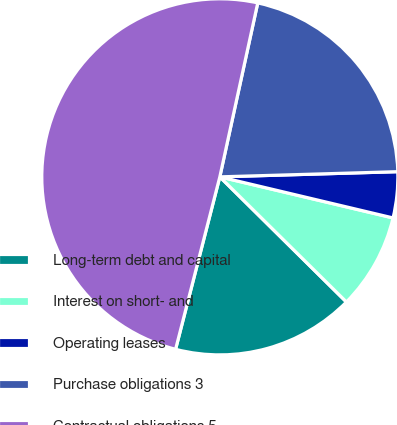Convert chart to OTSL. <chart><loc_0><loc_0><loc_500><loc_500><pie_chart><fcel>Long-term debt and capital<fcel>Interest on short- and<fcel>Operating leases<fcel>Purchase obligations 3<fcel>Contractual obligations 5<nl><fcel>16.59%<fcel>8.7%<fcel>4.17%<fcel>21.12%<fcel>49.42%<nl></chart> 